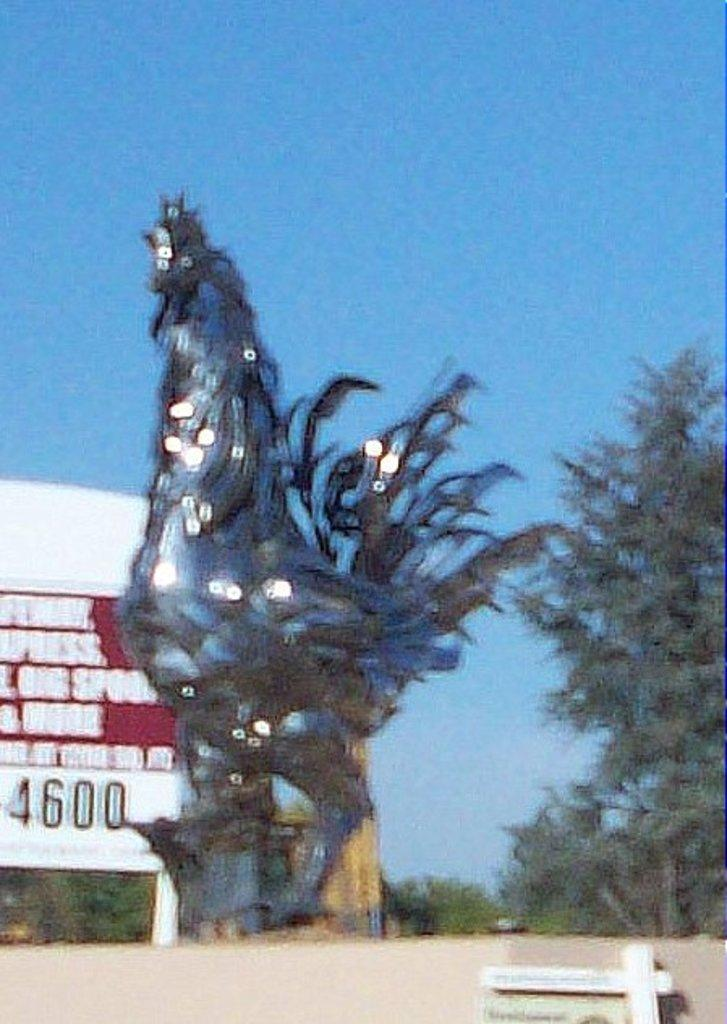What is the main subject in the center of the image? There is a statue in the center of the image. What can be seen in the background of the image? There are trees and a board in the background of the image. What is at the bottom of the image? There is a walkway at the bottom of the image. How many cherries are on the statue in the image? There are no cherries present on the statue in the image. What type of frog can be seen hopping on the walkway in the image? There is no frog present on the walkway in the image. 